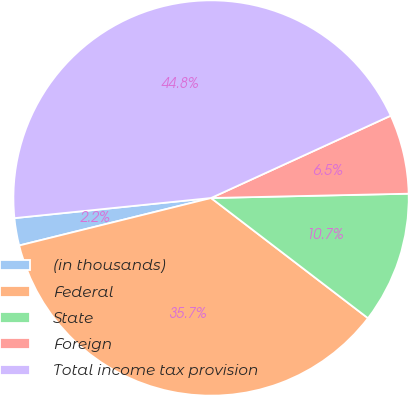Convert chart to OTSL. <chart><loc_0><loc_0><loc_500><loc_500><pie_chart><fcel>(in thousands)<fcel>Federal<fcel>State<fcel>Foreign<fcel>Total income tax provision<nl><fcel>2.24%<fcel>35.74%<fcel>10.75%<fcel>6.49%<fcel>44.79%<nl></chart> 